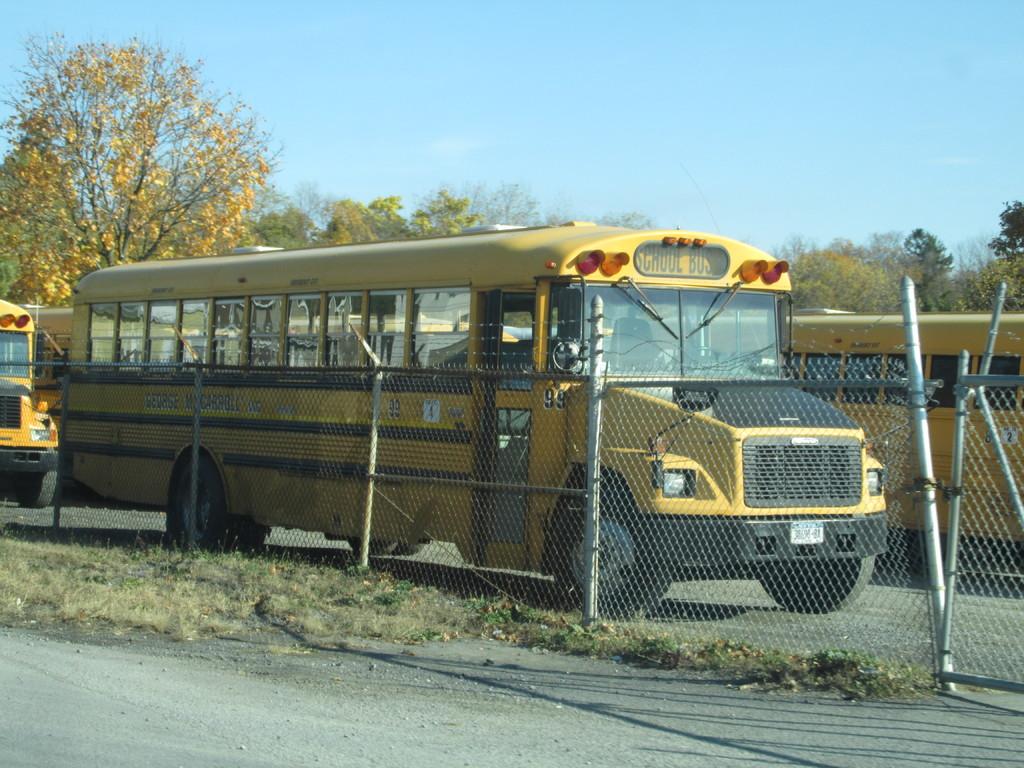What kind of bus is this?
Make the answer very short. School. What is the number of the bus?
Give a very brief answer. 99. 